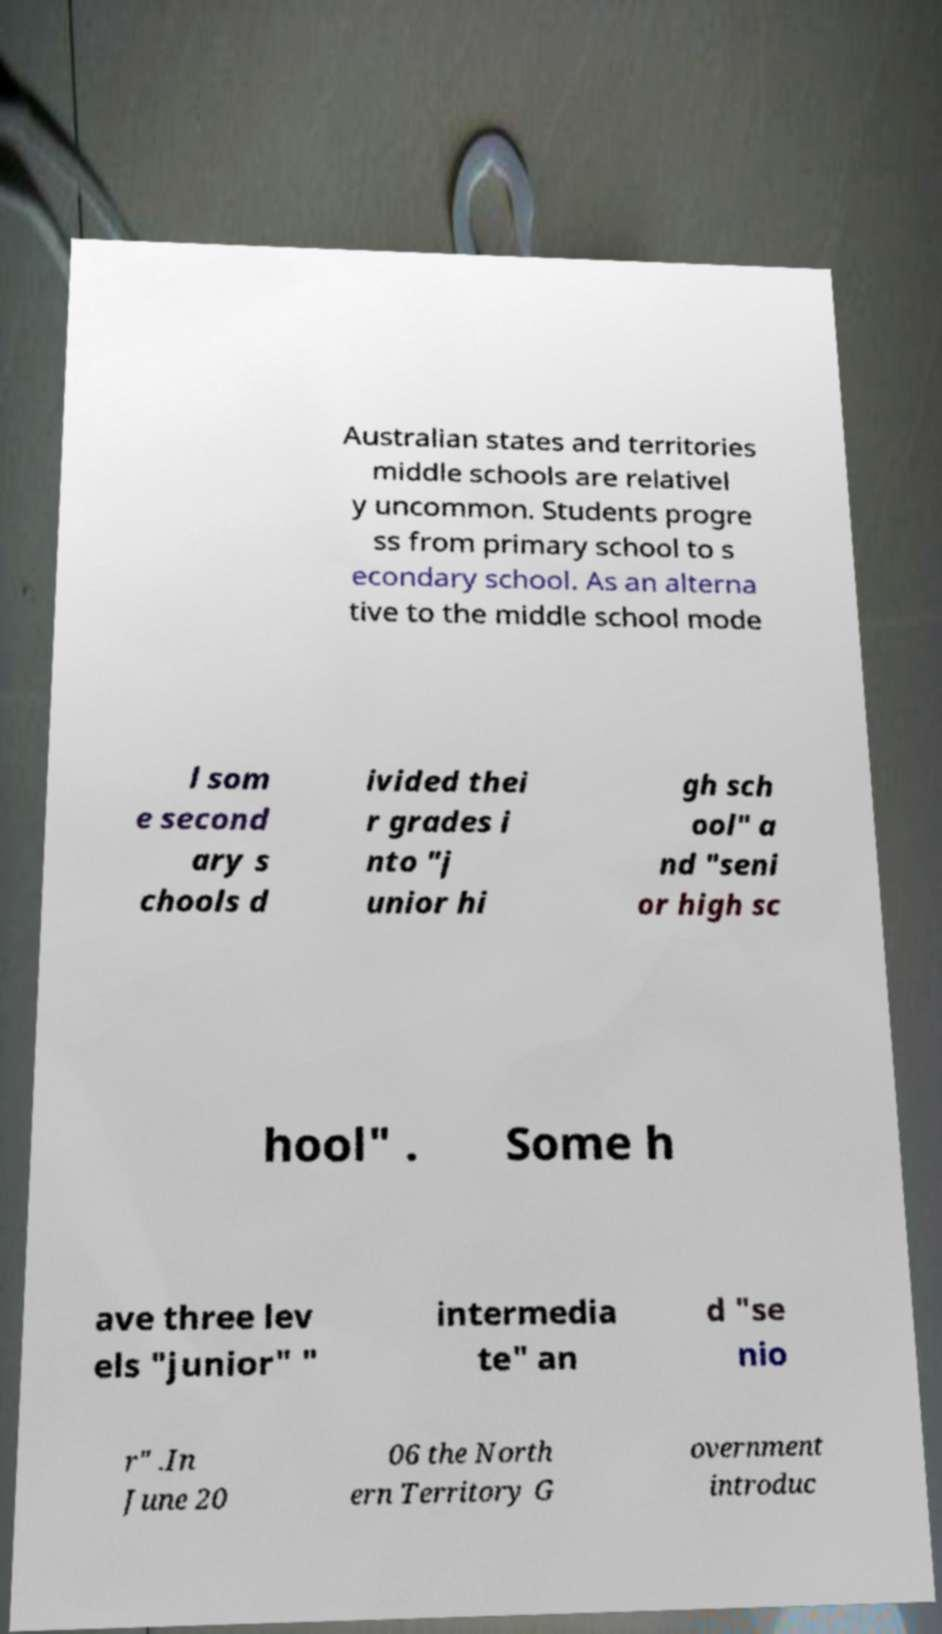Can you accurately transcribe the text from the provided image for me? Australian states and territories middle schools are relativel y uncommon. Students progre ss from primary school to s econdary school. As an alterna tive to the middle school mode l som e second ary s chools d ivided thei r grades i nto "j unior hi gh sch ool" a nd "seni or high sc hool" . Some h ave three lev els "junior" " intermedia te" an d "se nio r" .In June 20 06 the North ern Territory G overnment introduc 